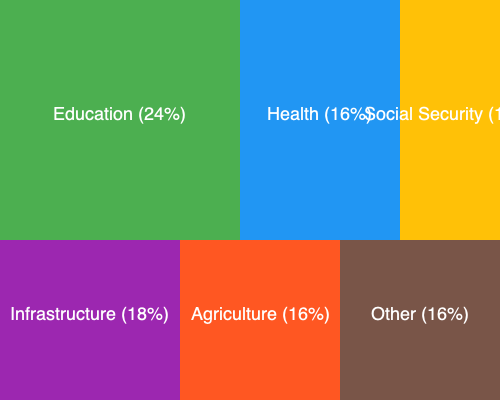Based on the treemap diagram showing Mauritius' budget allocation, which sector receives the highest percentage of funding, and what innovative policy could be proposed to enhance its effectiveness while promoting progressive values? To answer this question, we need to follow these steps:

1. Analyze the treemap diagram:
   - Education: 24%
   - Health: 16%
   - Social Security: 10%
   - Infrastructure: 18%
   - Agriculture: 16%
   - Other: 16%

2. Identify the sector with the highest percentage:
   Education receives the highest allocation at 24% of the budget.

3. Consider an innovative policy to enhance its effectiveness while promoting progressive values:
   - Implement a comprehensive digital literacy program across all educational levels
   - This aligns with progressive values by:
     a) Reducing the digital divide
     b) Preparing students for the future job market
     c) Promoting equal access to digital resources
     d) Encouraging innovation and technological advancement

4. Outline the policy proposal:
   "Implement a nation-wide Digital Literacy Initiative in schools, providing students with access to cutting-edge technology, coding classes, and online learning resources. This program aims to bridge the digital divide, prepare students for future careers, and foster innovation in the education sector."

This policy proposal addresses the highest-funded sector (Education) while promoting progressive values such as equality, innovation, and future-oriented thinking.
Answer: Education (24%); Implement a nation-wide Digital Literacy Initiative in schools. 